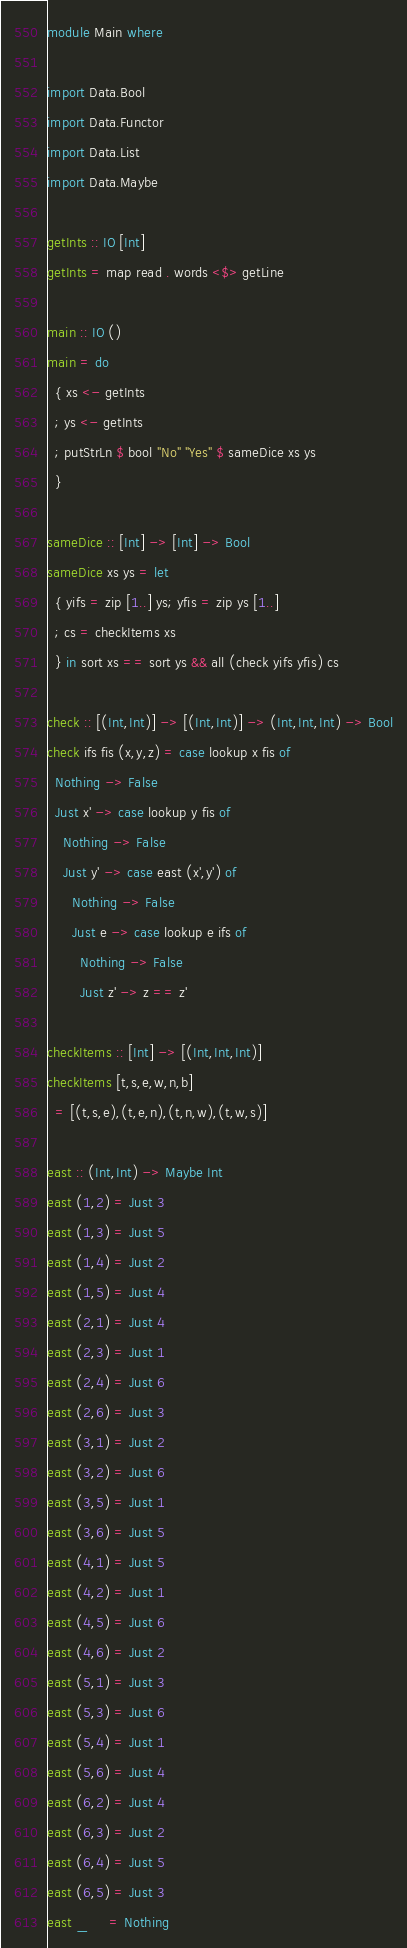Convert code to text. <code><loc_0><loc_0><loc_500><loc_500><_Haskell_>module Main where

import Data.Bool
import Data.Functor
import Data.List
import Data.Maybe

getInts :: IO [Int]
getInts = map read . words <$> getLine

main :: IO ()
main = do
  { xs <- getInts
  ; ys <- getInts
  ; putStrLn $ bool "No" "Yes" $ sameDice xs ys
  }

sameDice :: [Int] -> [Int] -> Bool
sameDice xs ys = let
  { yifs = zip [1..] ys; yfis = zip ys [1..]
  ; cs = checkItems xs
  } in sort xs == sort ys && all (check yifs yfis) cs

check :: [(Int,Int)] -> [(Int,Int)] -> (Int,Int,Int) -> Bool
check ifs fis (x,y,z) = case lookup x fis of
  Nothing -> False
  Just x' -> case lookup y fis of
    Nothing -> False
    Just y' -> case east (x',y') of
      Nothing -> False
      Just e -> case lookup e ifs of
        Nothing -> False
        Just z' -> z == z'

checkItems :: [Int] -> [(Int,Int,Int)]
checkItems [t,s,e,w,n,b]
  = [(t,s,e),(t,e,n),(t,n,w),(t,w,s)]

east :: (Int,Int) -> Maybe Int
east (1,2) = Just 3
east (1,3) = Just 5
east (1,4) = Just 2
east (1,5) = Just 4
east (2,1) = Just 4
east (2,3) = Just 1
east (2,4) = Just 6
east (2,6) = Just 3
east (3,1) = Just 2
east (3,2) = Just 6
east (3,5) = Just 1
east (3,6) = Just 5
east (4,1) = Just 5
east (4,2) = Just 1
east (4,5) = Just 6
east (4,6) = Just 2
east (5,1) = Just 3
east (5,3) = Just 6
east (5,4) = Just 1
east (5,6) = Just 4
east (6,2) = Just 4
east (6,3) = Just 2
east (6,4) = Just 5
east (6,5) = Just 3
east _     = Nothing</code> 